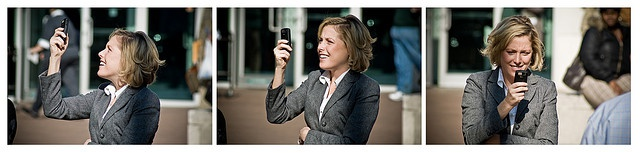Describe the objects in this image and their specific colors. I can see people in white, black, gray, and tan tones, people in white, black, gray, and darkgray tones, people in white, black, gray, and lightgray tones, people in white, black, tan, and maroon tones, and people in white, black, blue, teal, and darkblue tones in this image. 